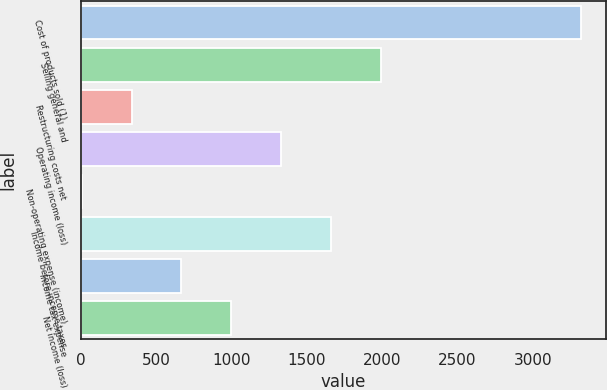Convert chart to OTSL. <chart><loc_0><loc_0><loc_500><loc_500><bar_chart><fcel>Cost of products sold (1)<fcel>Selling general and<fcel>Restructuring costs net<fcel>Operating income (loss)<fcel>Non-operating expense (income)<fcel>Income before income taxes<fcel>Income tax expense<fcel>Net income (loss)<nl><fcel>3316.5<fcel>1992.66<fcel>337.86<fcel>1330.74<fcel>6.9<fcel>1661.7<fcel>668.82<fcel>999.78<nl></chart> 